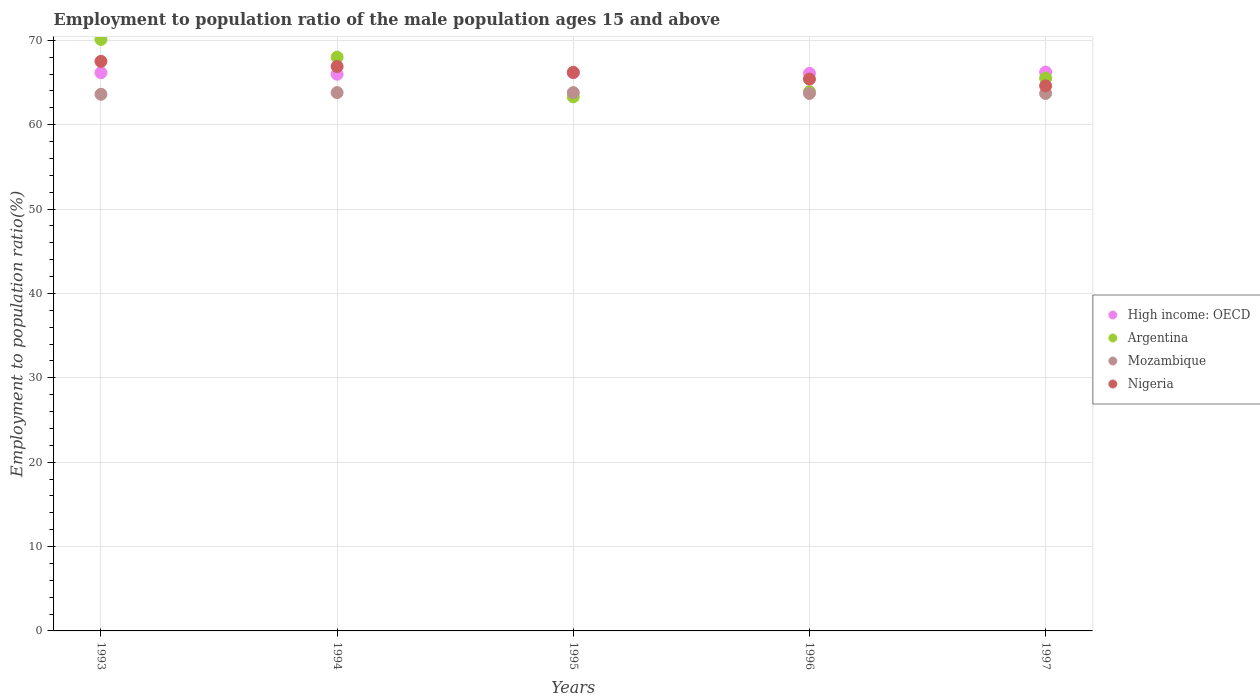What is the employment to population ratio in Nigeria in 1994?
Provide a short and direct response. 66.9. Across all years, what is the maximum employment to population ratio in Nigeria?
Your answer should be compact. 67.5. Across all years, what is the minimum employment to population ratio in Mozambique?
Your answer should be compact. 63.6. In which year was the employment to population ratio in Nigeria maximum?
Provide a succinct answer. 1993. In which year was the employment to population ratio in High income: OECD minimum?
Give a very brief answer. 1994. What is the total employment to population ratio in Argentina in the graph?
Provide a succinct answer. 330.8. What is the difference between the employment to population ratio in High income: OECD in 1995 and that in 1997?
Keep it short and to the point. -0.08. What is the difference between the employment to population ratio in High income: OECD in 1994 and the employment to population ratio in Nigeria in 1997?
Make the answer very short. 1.38. What is the average employment to population ratio in Mozambique per year?
Your response must be concise. 63.72. In the year 1994, what is the difference between the employment to population ratio in Nigeria and employment to population ratio in Mozambique?
Your answer should be compact. 3.1. What is the ratio of the employment to population ratio in Nigeria in 1995 to that in 1996?
Give a very brief answer. 1.01. Is the employment to population ratio in Argentina in 1993 less than that in 1996?
Offer a terse response. No. Is the difference between the employment to population ratio in Nigeria in 1993 and 1996 greater than the difference between the employment to population ratio in Mozambique in 1993 and 1996?
Keep it short and to the point. Yes. What is the difference between the highest and the second highest employment to population ratio in Nigeria?
Give a very brief answer. 0.6. What is the difference between the highest and the lowest employment to population ratio in Nigeria?
Offer a terse response. 2.9. In how many years, is the employment to population ratio in Mozambique greater than the average employment to population ratio in Mozambique taken over all years?
Make the answer very short. 2. Is the sum of the employment to population ratio in Mozambique in 1995 and 1996 greater than the maximum employment to population ratio in Argentina across all years?
Your answer should be compact. Yes. Is it the case that in every year, the sum of the employment to population ratio in Nigeria and employment to population ratio in Argentina  is greater than the sum of employment to population ratio in High income: OECD and employment to population ratio in Mozambique?
Give a very brief answer. Yes. Is it the case that in every year, the sum of the employment to population ratio in Nigeria and employment to population ratio in High income: OECD  is greater than the employment to population ratio in Mozambique?
Provide a short and direct response. Yes. Are the values on the major ticks of Y-axis written in scientific E-notation?
Your answer should be compact. No. Does the graph contain grids?
Provide a succinct answer. Yes. How many legend labels are there?
Your answer should be very brief. 4. How are the legend labels stacked?
Your response must be concise. Vertical. What is the title of the graph?
Your answer should be compact. Employment to population ratio of the male population ages 15 and above. What is the label or title of the X-axis?
Offer a very short reply. Years. What is the label or title of the Y-axis?
Your answer should be very brief. Employment to population ratio(%). What is the Employment to population ratio(%) in High income: OECD in 1993?
Provide a short and direct response. 66.16. What is the Employment to population ratio(%) in Argentina in 1993?
Offer a very short reply. 70.1. What is the Employment to population ratio(%) in Mozambique in 1993?
Provide a succinct answer. 63.6. What is the Employment to population ratio(%) in Nigeria in 1993?
Provide a short and direct response. 67.5. What is the Employment to population ratio(%) of High income: OECD in 1994?
Your response must be concise. 65.98. What is the Employment to population ratio(%) of Argentina in 1994?
Keep it short and to the point. 68. What is the Employment to population ratio(%) in Mozambique in 1994?
Ensure brevity in your answer.  63.8. What is the Employment to population ratio(%) of Nigeria in 1994?
Ensure brevity in your answer.  66.9. What is the Employment to population ratio(%) in High income: OECD in 1995?
Your response must be concise. 66.15. What is the Employment to population ratio(%) in Argentina in 1995?
Provide a succinct answer. 63.3. What is the Employment to population ratio(%) of Mozambique in 1995?
Make the answer very short. 63.8. What is the Employment to population ratio(%) in Nigeria in 1995?
Give a very brief answer. 66.2. What is the Employment to population ratio(%) of High income: OECD in 1996?
Provide a short and direct response. 66.08. What is the Employment to population ratio(%) of Argentina in 1996?
Your answer should be very brief. 63.9. What is the Employment to population ratio(%) of Mozambique in 1996?
Your answer should be very brief. 63.7. What is the Employment to population ratio(%) of Nigeria in 1996?
Your answer should be very brief. 65.4. What is the Employment to population ratio(%) in High income: OECD in 1997?
Your answer should be compact. 66.23. What is the Employment to population ratio(%) in Argentina in 1997?
Offer a terse response. 65.5. What is the Employment to population ratio(%) of Mozambique in 1997?
Keep it short and to the point. 63.7. What is the Employment to population ratio(%) of Nigeria in 1997?
Ensure brevity in your answer.  64.6. Across all years, what is the maximum Employment to population ratio(%) of High income: OECD?
Offer a very short reply. 66.23. Across all years, what is the maximum Employment to population ratio(%) of Argentina?
Your response must be concise. 70.1. Across all years, what is the maximum Employment to population ratio(%) of Mozambique?
Keep it short and to the point. 63.8. Across all years, what is the maximum Employment to population ratio(%) of Nigeria?
Offer a terse response. 67.5. Across all years, what is the minimum Employment to population ratio(%) of High income: OECD?
Your response must be concise. 65.98. Across all years, what is the minimum Employment to population ratio(%) of Argentina?
Give a very brief answer. 63.3. Across all years, what is the minimum Employment to population ratio(%) in Mozambique?
Your response must be concise. 63.6. Across all years, what is the minimum Employment to population ratio(%) of Nigeria?
Your answer should be compact. 64.6. What is the total Employment to population ratio(%) in High income: OECD in the graph?
Your answer should be compact. 330.6. What is the total Employment to population ratio(%) in Argentina in the graph?
Ensure brevity in your answer.  330.8. What is the total Employment to population ratio(%) in Mozambique in the graph?
Ensure brevity in your answer.  318.6. What is the total Employment to population ratio(%) in Nigeria in the graph?
Offer a terse response. 330.6. What is the difference between the Employment to population ratio(%) of High income: OECD in 1993 and that in 1994?
Offer a very short reply. 0.18. What is the difference between the Employment to population ratio(%) of Nigeria in 1993 and that in 1994?
Provide a short and direct response. 0.6. What is the difference between the Employment to population ratio(%) in High income: OECD in 1993 and that in 1995?
Keep it short and to the point. 0.01. What is the difference between the Employment to population ratio(%) of High income: OECD in 1993 and that in 1996?
Your answer should be compact. 0.08. What is the difference between the Employment to population ratio(%) of Mozambique in 1993 and that in 1996?
Provide a succinct answer. -0.1. What is the difference between the Employment to population ratio(%) in Nigeria in 1993 and that in 1996?
Offer a terse response. 2.1. What is the difference between the Employment to population ratio(%) of High income: OECD in 1993 and that in 1997?
Provide a short and direct response. -0.07. What is the difference between the Employment to population ratio(%) of Argentina in 1993 and that in 1997?
Offer a terse response. 4.6. What is the difference between the Employment to population ratio(%) of Nigeria in 1993 and that in 1997?
Your answer should be compact. 2.9. What is the difference between the Employment to population ratio(%) in High income: OECD in 1994 and that in 1995?
Your answer should be compact. -0.17. What is the difference between the Employment to population ratio(%) in Nigeria in 1994 and that in 1995?
Ensure brevity in your answer.  0.7. What is the difference between the Employment to population ratio(%) of High income: OECD in 1994 and that in 1996?
Your response must be concise. -0.1. What is the difference between the Employment to population ratio(%) of High income: OECD in 1994 and that in 1997?
Your answer should be compact. -0.25. What is the difference between the Employment to population ratio(%) of Argentina in 1994 and that in 1997?
Your answer should be compact. 2.5. What is the difference between the Employment to population ratio(%) of High income: OECD in 1995 and that in 1996?
Your answer should be very brief. 0.07. What is the difference between the Employment to population ratio(%) in Nigeria in 1995 and that in 1996?
Offer a terse response. 0.8. What is the difference between the Employment to population ratio(%) of High income: OECD in 1995 and that in 1997?
Provide a short and direct response. -0.08. What is the difference between the Employment to population ratio(%) of Argentina in 1995 and that in 1997?
Offer a very short reply. -2.2. What is the difference between the Employment to population ratio(%) in High income: OECD in 1996 and that in 1997?
Provide a succinct answer. -0.15. What is the difference between the Employment to population ratio(%) of Argentina in 1996 and that in 1997?
Provide a short and direct response. -1.6. What is the difference between the Employment to population ratio(%) of Mozambique in 1996 and that in 1997?
Offer a very short reply. 0. What is the difference between the Employment to population ratio(%) of High income: OECD in 1993 and the Employment to population ratio(%) of Argentina in 1994?
Your answer should be compact. -1.84. What is the difference between the Employment to population ratio(%) in High income: OECD in 1993 and the Employment to population ratio(%) in Mozambique in 1994?
Your answer should be very brief. 2.36. What is the difference between the Employment to population ratio(%) in High income: OECD in 1993 and the Employment to population ratio(%) in Nigeria in 1994?
Give a very brief answer. -0.74. What is the difference between the Employment to population ratio(%) in Argentina in 1993 and the Employment to population ratio(%) in Nigeria in 1994?
Provide a short and direct response. 3.2. What is the difference between the Employment to population ratio(%) in High income: OECD in 1993 and the Employment to population ratio(%) in Argentina in 1995?
Offer a very short reply. 2.86. What is the difference between the Employment to population ratio(%) in High income: OECD in 1993 and the Employment to population ratio(%) in Mozambique in 1995?
Ensure brevity in your answer.  2.36. What is the difference between the Employment to population ratio(%) of High income: OECD in 1993 and the Employment to population ratio(%) of Nigeria in 1995?
Keep it short and to the point. -0.04. What is the difference between the Employment to population ratio(%) of Argentina in 1993 and the Employment to population ratio(%) of Nigeria in 1995?
Make the answer very short. 3.9. What is the difference between the Employment to population ratio(%) in High income: OECD in 1993 and the Employment to population ratio(%) in Argentina in 1996?
Ensure brevity in your answer.  2.26. What is the difference between the Employment to population ratio(%) in High income: OECD in 1993 and the Employment to population ratio(%) in Mozambique in 1996?
Provide a succinct answer. 2.46. What is the difference between the Employment to population ratio(%) in High income: OECD in 1993 and the Employment to population ratio(%) in Nigeria in 1996?
Your answer should be compact. 0.76. What is the difference between the Employment to population ratio(%) in Argentina in 1993 and the Employment to population ratio(%) in Nigeria in 1996?
Give a very brief answer. 4.7. What is the difference between the Employment to population ratio(%) in Mozambique in 1993 and the Employment to population ratio(%) in Nigeria in 1996?
Give a very brief answer. -1.8. What is the difference between the Employment to population ratio(%) in High income: OECD in 1993 and the Employment to population ratio(%) in Argentina in 1997?
Keep it short and to the point. 0.66. What is the difference between the Employment to population ratio(%) in High income: OECD in 1993 and the Employment to population ratio(%) in Mozambique in 1997?
Offer a terse response. 2.46. What is the difference between the Employment to population ratio(%) in High income: OECD in 1993 and the Employment to population ratio(%) in Nigeria in 1997?
Offer a very short reply. 1.56. What is the difference between the Employment to population ratio(%) in Argentina in 1993 and the Employment to population ratio(%) in Nigeria in 1997?
Offer a terse response. 5.5. What is the difference between the Employment to population ratio(%) of High income: OECD in 1994 and the Employment to population ratio(%) of Argentina in 1995?
Keep it short and to the point. 2.68. What is the difference between the Employment to population ratio(%) in High income: OECD in 1994 and the Employment to population ratio(%) in Mozambique in 1995?
Keep it short and to the point. 2.18. What is the difference between the Employment to population ratio(%) of High income: OECD in 1994 and the Employment to population ratio(%) of Nigeria in 1995?
Your answer should be compact. -0.22. What is the difference between the Employment to population ratio(%) of Argentina in 1994 and the Employment to population ratio(%) of Mozambique in 1995?
Offer a very short reply. 4.2. What is the difference between the Employment to population ratio(%) of Argentina in 1994 and the Employment to population ratio(%) of Nigeria in 1995?
Keep it short and to the point. 1.8. What is the difference between the Employment to population ratio(%) in High income: OECD in 1994 and the Employment to population ratio(%) in Argentina in 1996?
Offer a terse response. 2.08. What is the difference between the Employment to population ratio(%) of High income: OECD in 1994 and the Employment to population ratio(%) of Mozambique in 1996?
Keep it short and to the point. 2.28. What is the difference between the Employment to population ratio(%) in High income: OECD in 1994 and the Employment to population ratio(%) in Nigeria in 1996?
Provide a short and direct response. 0.58. What is the difference between the Employment to population ratio(%) of Argentina in 1994 and the Employment to population ratio(%) of Nigeria in 1996?
Give a very brief answer. 2.6. What is the difference between the Employment to population ratio(%) in Mozambique in 1994 and the Employment to population ratio(%) in Nigeria in 1996?
Provide a short and direct response. -1.6. What is the difference between the Employment to population ratio(%) of High income: OECD in 1994 and the Employment to population ratio(%) of Argentina in 1997?
Provide a succinct answer. 0.48. What is the difference between the Employment to population ratio(%) in High income: OECD in 1994 and the Employment to population ratio(%) in Mozambique in 1997?
Offer a terse response. 2.28. What is the difference between the Employment to population ratio(%) of High income: OECD in 1994 and the Employment to population ratio(%) of Nigeria in 1997?
Ensure brevity in your answer.  1.38. What is the difference between the Employment to population ratio(%) of Argentina in 1994 and the Employment to population ratio(%) of Mozambique in 1997?
Ensure brevity in your answer.  4.3. What is the difference between the Employment to population ratio(%) in Mozambique in 1994 and the Employment to population ratio(%) in Nigeria in 1997?
Offer a terse response. -0.8. What is the difference between the Employment to population ratio(%) in High income: OECD in 1995 and the Employment to population ratio(%) in Argentina in 1996?
Provide a short and direct response. 2.25. What is the difference between the Employment to population ratio(%) in High income: OECD in 1995 and the Employment to population ratio(%) in Mozambique in 1996?
Your answer should be very brief. 2.45. What is the difference between the Employment to population ratio(%) of High income: OECD in 1995 and the Employment to population ratio(%) of Nigeria in 1996?
Ensure brevity in your answer.  0.75. What is the difference between the Employment to population ratio(%) of Argentina in 1995 and the Employment to population ratio(%) of Mozambique in 1996?
Your answer should be compact. -0.4. What is the difference between the Employment to population ratio(%) in Argentina in 1995 and the Employment to population ratio(%) in Nigeria in 1996?
Offer a very short reply. -2.1. What is the difference between the Employment to population ratio(%) in High income: OECD in 1995 and the Employment to population ratio(%) in Argentina in 1997?
Provide a succinct answer. 0.65. What is the difference between the Employment to population ratio(%) of High income: OECD in 1995 and the Employment to population ratio(%) of Mozambique in 1997?
Offer a terse response. 2.45. What is the difference between the Employment to population ratio(%) in High income: OECD in 1995 and the Employment to population ratio(%) in Nigeria in 1997?
Ensure brevity in your answer.  1.55. What is the difference between the Employment to population ratio(%) in Argentina in 1995 and the Employment to population ratio(%) in Mozambique in 1997?
Provide a short and direct response. -0.4. What is the difference between the Employment to population ratio(%) in Mozambique in 1995 and the Employment to population ratio(%) in Nigeria in 1997?
Offer a very short reply. -0.8. What is the difference between the Employment to population ratio(%) of High income: OECD in 1996 and the Employment to population ratio(%) of Argentina in 1997?
Give a very brief answer. 0.58. What is the difference between the Employment to population ratio(%) of High income: OECD in 1996 and the Employment to population ratio(%) of Mozambique in 1997?
Make the answer very short. 2.38. What is the difference between the Employment to population ratio(%) of High income: OECD in 1996 and the Employment to population ratio(%) of Nigeria in 1997?
Keep it short and to the point. 1.48. What is the difference between the Employment to population ratio(%) in Argentina in 1996 and the Employment to population ratio(%) in Mozambique in 1997?
Keep it short and to the point. 0.2. What is the difference between the Employment to population ratio(%) in Argentina in 1996 and the Employment to population ratio(%) in Nigeria in 1997?
Ensure brevity in your answer.  -0.7. What is the difference between the Employment to population ratio(%) in Mozambique in 1996 and the Employment to population ratio(%) in Nigeria in 1997?
Offer a terse response. -0.9. What is the average Employment to population ratio(%) of High income: OECD per year?
Ensure brevity in your answer.  66.12. What is the average Employment to population ratio(%) of Argentina per year?
Offer a terse response. 66.16. What is the average Employment to population ratio(%) in Mozambique per year?
Your answer should be very brief. 63.72. What is the average Employment to population ratio(%) of Nigeria per year?
Keep it short and to the point. 66.12. In the year 1993, what is the difference between the Employment to population ratio(%) of High income: OECD and Employment to population ratio(%) of Argentina?
Offer a terse response. -3.94. In the year 1993, what is the difference between the Employment to population ratio(%) of High income: OECD and Employment to population ratio(%) of Mozambique?
Give a very brief answer. 2.56. In the year 1993, what is the difference between the Employment to population ratio(%) of High income: OECD and Employment to population ratio(%) of Nigeria?
Make the answer very short. -1.34. In the year 1993, what is the difference between the Employment to population ratio(%) of Argentina and Employment to population ratio(%) of Nigeria?
Provide a succinct answer. 2.6. In the year 1994, what is the difference between the Employment to population ratio(%) in High income: OECD and Employment to population ratio(%) in Argentina?
Keep it short and to the point. -2.02. In the year 1994, what is the difference between the Employment to population ratio(%) in High income: OECD and Employment to population ratio(%) in Mozambique?
Provide a short and direct response. 2.18. In the year 1994, what is the difference between the Employment to population ratio(%) in High income: OECD and Employment to population ratio(%) in Nigeria?
Your response must be concise. -0.92. In the year 1994, what is the difference between the Employment to population ratio(%) in Argentina and Employment to population ratio(%) in Mozambique?
Offer a very short reply. 4.2. In the year 1994, what is the difference between the Employment to population ratio(%) of Argentina and Employment to population ratio(%) of Nigeria?
Offer a very short reply. 1.1. In the year 1994, what is the difference between the Employment to population ratio(%) in Mozambique and Employment to population ratio(%) in Nigeria?
Ensure brevity in your answer.  -3.1. In the year 1995, what is the difference between the Employment to population ratio(%) in High income: OECD and Employment to population ratio(%) in Argentina?
Offer a very short reply. 2.85. In the year 1995, what is the difference between the Employment to population ratio(%) in High income: OECD and Employment to population ratio(%) in Mozambique?
Your response must be concise. 2.35. In the year 1995, what is the difference between the Employment to population ratio(%) in High income: OECD and Employment to population ratio(%) in Nigeria?
Your response must be concise. -0.05. In the year 1995, what is the difference between the Employment to population ratio(%) in Argentina and Employment to population ratio(%) in Mozambique?
Your answer should be very brief. -0.5. In the year 1995, what is the difference between the Employment to population ratio(%) in Argentina and Employment to population ratio(%) in Nigeria?
Make the answer very short. -2.9. In the year 1995, what is the difference between the Employment to population ratio(%) in Mozambique and Employment to population ratio(%) in Nigeria?
Your response must be concise. -2.4. In the year 1996, what is the difference between the Employment to population ratio(%) of High income: OECD and Employment to population ratio(%) of Argentina?
Make the answer very short. 2.18. In the year 1996, what is the difference between the Employment to population ratio(%) in High income: OECD and Employment to population ratio(%) in Mozambique?
Offer a terse response. 2.38. In the year 1996, what is the difference between the Employment to population ratio(%) in High income: OECD and Employment to population ratio(%) in Nigeria?
Give a very brief answer. 0.68. In the year 1996, what is the difference between the Employment to population ratio(%) in Mozambique and Employment to population ratio(%) in Nigeria?
Offer a terse response. -1.7. In the year 1997, what is the difference between the Employment to population ratio(%) in High income: OECD and Employment to population ratio(%) in Argentina?
Provide a succinct answer. 0.73. In the year 1997, what is the difference between the Employment to population ratio(%) of High income: OECD and Employment to population ratio(%) of Mozambique?
Provide a succinct answer. 2.53. In the year 1997, what is the difference between the Employment to population ratio(%) in High income: OECD and Employment to population ratio(%) in Nigeria?
Ensure brevity in your answer.  1.63. In the year 1997, what is the difference between the Employment to population ratio(%) in Argentina and Employment to population ratio(%) in Nigeria?
Your answer should be very brief. 0.9. In the year 1997, what is the difference between the Employment to population ratio(%) of Mozambique and Employment to population ratio(%) of Nigeria?
Keep it short and to the point. -0.9. What is the ratio of the Employment to population ratio(%) in Argentina in 1993 to that in 1994?
Your answer should be compact. 1.03. What is the ratio of the Employment to population ratio(%) in Mozambique in 1993 to that in 1994?
Your response must be concise. 1. What is the ratio of the Employment to population ratio(%) in High income: OECD in 1993 to that in 1995?
Offer a very short reply. 1. What is the ratio of the Employment to population ratio(%) of Argentina in 1993 to that in 1995?
Provide a succinct answer. 1.11. What is the ratio of the Employment to population ratio(%) in Nigeria in 1993 to that in 1995?
Give a very brief answer. 1.02. What is the ratio of the Employment to population ratio(%) of Argentina in 1993 to that in 1996?
Give a very brief answer. 1.1. What is the ratio of the Employment to population ratio(%) of Mozambique in 1993 to that in 1996?
Keep it short and to the point. 1. What is the ratio of the Employment to population ratio(%) in Nigeria in 1993 to that in 1996?
Provide a short and direct response. 1.03. What is the ratio of the Employment to population ratio(%) of Argentina in 1993 to that in 1997?
Keep it short and to the point. 1.07. What is the ratio of the Employment to population ratio(%) in Mozambique in 1993 to that in 1997?
Keep it short and to the point. 1. What is the ratio of the Employment to population ratio(%) in Nigeria in 1993 to that in 1997?
Offer a terse response. 1.04. What is the ratio of the Employment to population ratio(%) in Argentina in 1994 to that in 1995?
Your answer should be compact. 1.07. What is the ratio of the Employment to population ratio(%) in Nigeria in 1994 to that in 1995?
Your answer should be compact. 1.01. What is the ratio of the Employment to population ratio(%) of High income: OECD in 1994 to that in 1996?
Provide a short and direct response. 1. What is the ratio of the Employment to population ratio(%) of Argentina in 1994 to that in 1996?
Offer a very short reply. 1.06. What is the ratio of the Employment to population ratio(%) of Mozambique in 1994 to that in 1996?
Keep it short and to the point. 1. What is the ratio of the Employment to population ratio(%) in Nigeria in 1994 to that in 1996?
Your answer should be compact. 1.02. What is the ratio of the Employment to population ratio(%) of High income: OECD in 1994 to that in 1997?
Ensure brevity in your answer.  1. What is the ratio of the Employment to population ratio(%) in Argentina in 1994 to that in 1997?
Ensure brevity in your answer.  1.04. What is the ratio of the Employment to population ratio(%) of Nigeria in 1994 to that in 1997?
Your response must be concise. 1.04. What is the ratio of the Employment to population ratio(%) in Argentina in 1995 to that in 1996?
Give a very brief answer. 0.99. What is the ratio of the Employment to population ratio(%) of Mozambique in 1995 to that in 1996?
Provide a short and direct response. 1. What is the ratio of the Employment to population ratio(%) of Nigeria in 1995 to that in 1996?
Your answer should be very brief. 1.01. What is the ratio of the Employment to population ratio(%) in Argentina in 1995 to that in 1997?
Keep it short and to the point. 0.97. What is the ratio of the Employment to population ratio(%) of Mozambique in 1995 to that in 1997?
Make the answer very short. 1. What is the ratio of the Employment to population ratio(%) in Nigeria in 1995 to that in 1997?
Your answer should be compact. 1.02. What is the ratio of the Employment to population ratio(%) of Argentina in 1996 to that in 1997?
Give a very brief answer. 0.98. What is the ratio of the Employment to population ratio(%) in Nigeria in 1996 to that in 1997?
Give a very brief answer. 1.01. What is the difference between the highest and the second highest Employment to population ratio(%) of High income: OECD?
Offer a terse response. 0.07. What is the difference between the highest and the second highest Employment to population ratio(%) in Mozambique?
Offer a very short reply. 0. What is the difference between the highest and the lowest Employment to population ratio(%) in High income: OECD?
Your answer should be very brief. 0.25. What is the difference between the highest and the lowest Employment to population ratio(%) in Mozambique?
Make the answer very short. 0.2. What is the difference between the highest and the lowest Employment to population ratio(%) in Nigeria?
Provide a succinct answer. 2.9. 